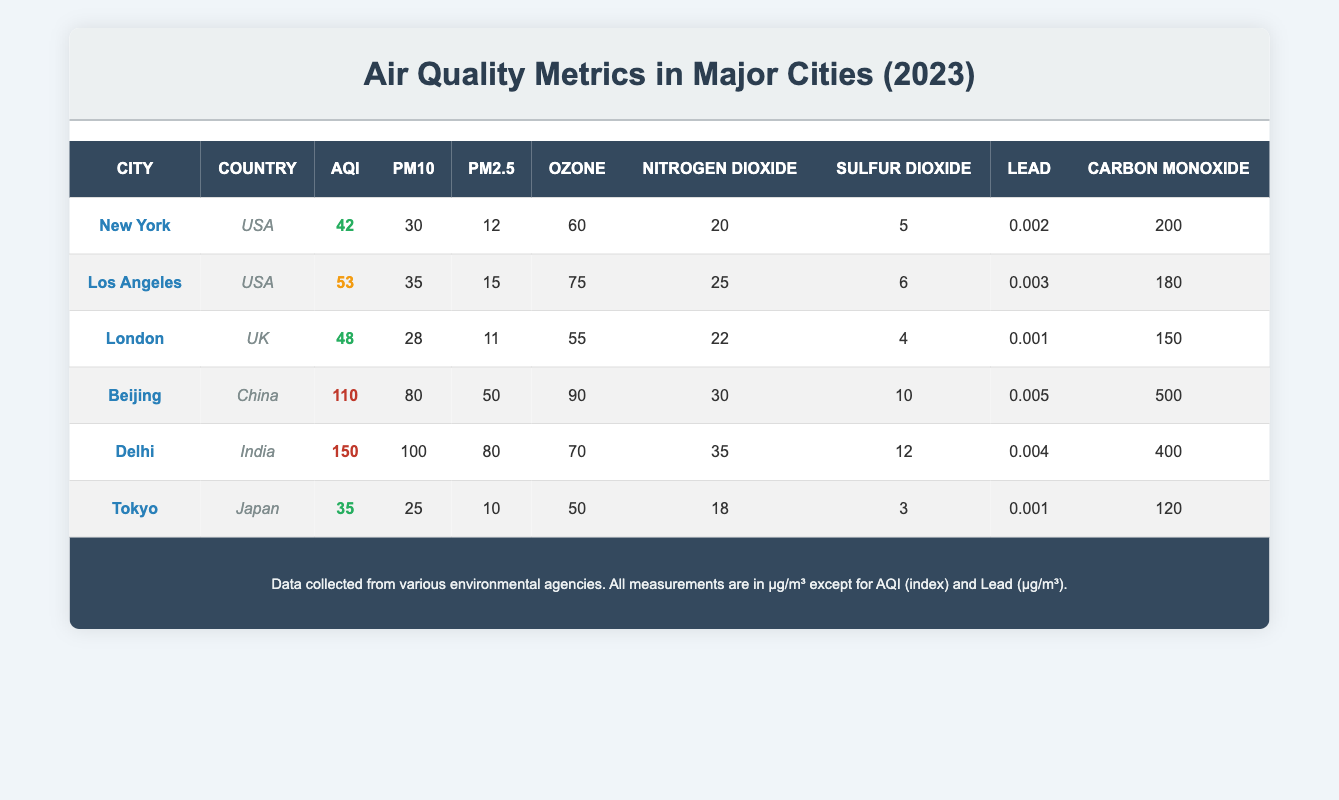What is the AQI of Tokyo? To find the AQI for Tokyo, you can look for the row that includes the city name "Tokyo." In that row, the AQI value is listed as 35.
Answer: 35 Which city has the highest PM2.5 level? To identify the city with the highest PM2.5 level, compare the PM2.5 values for all cities. The values are: New York (12), Los Angeles (15), London (11), Beijing (50), Delhi (80), and Tokyo (10). The highest value is 80, which corresponds to Delhi.
Answer: Delhi Is the Ozone level in Los Angeles greater than that in London? For Los Angeles, the Ozone level is 75, while for London, it is 55. Since 75 is greater than 55, the statement is true.
Answer: Yes What is the average AQI of all the cities listed? To calculate the average AQI, sum the AQI values of all cities: 42 (New York) + 53 (Los Angeles) + 48 (London) + 110 (Beijing) + 150 (Delhi) + 35 (Tokyo) = 438. There are 6 cities, so the average AQI is 438 divided by 6, which equals 73.
Answer: 73 Which city has lower Carbon Monoxide levels: London or Tokyo? London has a Carbon Monoxide level of 150, while Tokyo has a level of 120. Since 120 is less than 150, Tokyo has lower levels than London.
Answer: Tokyo What is the difference in PM10 levels between Delhi and New York? The PM10 level in Delhi is 100, and in New York, it is 30. To find the difference, subtract New York's PM10 from Delhi’s: 100 - 30 = 70.
Answer: 70 Does Beijing have a higher level of Nitrogen Dioxide compared to New York? The Nitrogen Dioxide level for Beijing is 30, and for New York, it is 20. Since 30 is greater than 20, the statement is true.
Answer: Yes What is the total Sulfur Dioxide level for all cities combined? To find the total Sulfur Dioxide level, add the values for each city: New York (5) + Los Angeles (6) + London (4) + Beijing (10) + Delhi (12) + Tokyo (3) = 40.
Answer: 40 Which city has the lowest AQI and what is that value? Review the AQI values: New York (42), Los Angeles (53), London (48), Beijing (110), Delhi (150), and Tokyo (35). The lowest AQI value is 35, which corresponds to Tokyo.
Answer: Tokyo, 35 